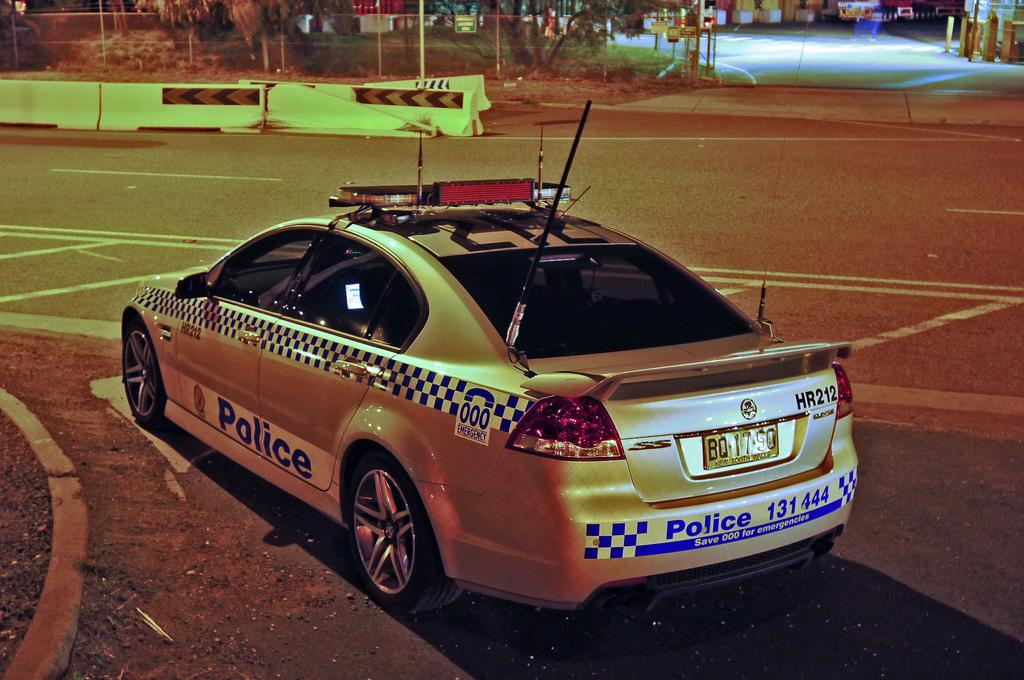What is the main subject of the image? There is a car in the image. Where is the car located? The car is on the road. What can be seen in the background of the image? There are boards, trees, and a fence in the background of the image. What type of pain is the car experiencing in the image? Cars do not experience pain, so this question cannot be answered. 